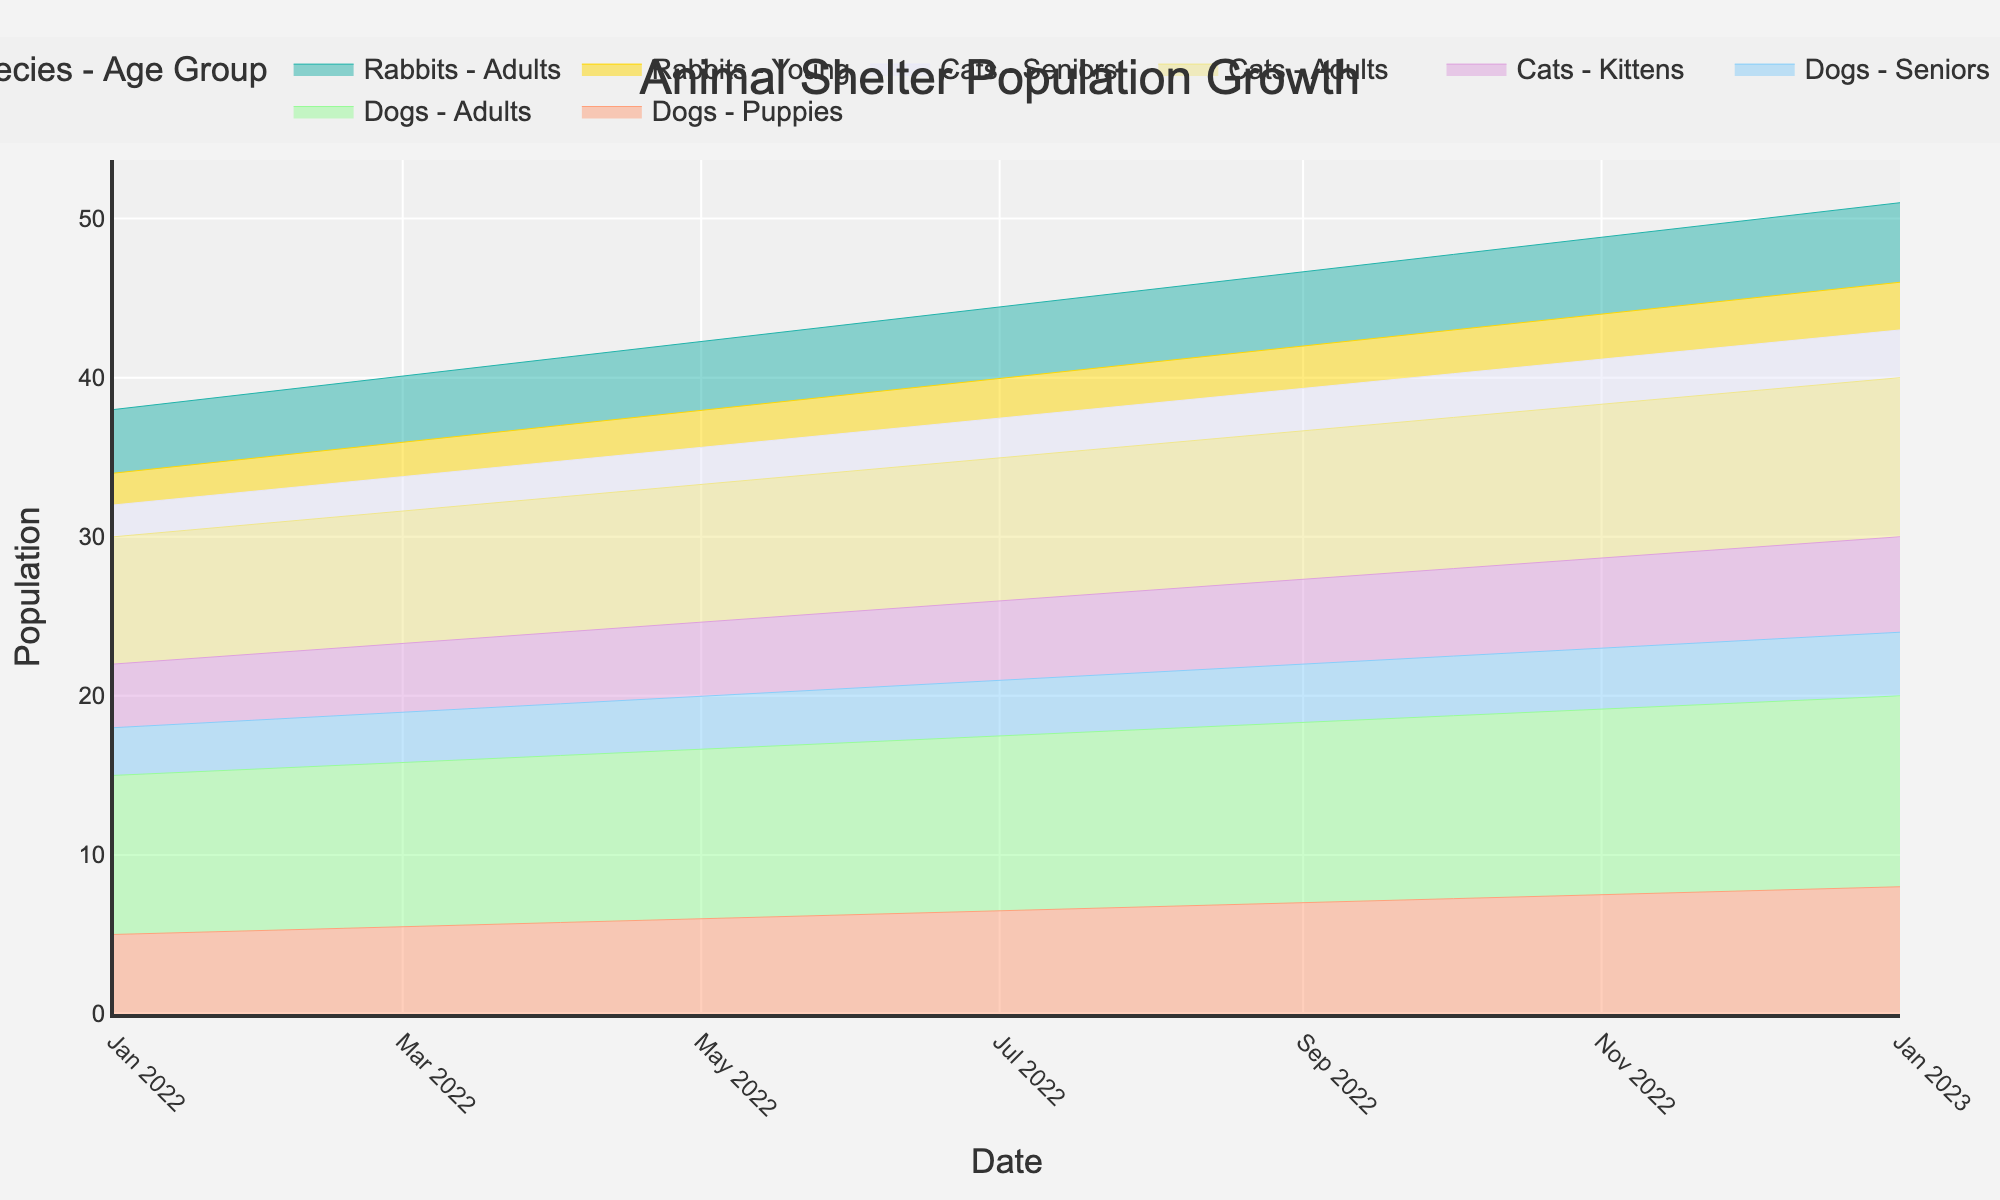What's the title of the figure? The title of the figure is placed at the top and it summarizes the main subject of the graph. Here, it says "Animal Shelter Population Growth".
Answer: Animal Shelter Population Growth What is the population of adult cats on January 1, 2023? Look for the data point on the stream graph under "Cats - Adults" for the date January 1, 2023. The corresponding population value is 10.
Answer: 10 Which species and age group had the highest population on January 1, 2023? Look across the various colored regions on the graph to find the highest line at the date January 1, 2023. The group "Dogs - Adults" had the highest population with a count of 12.
Answer: Dogs - Adults By how many did the population of puppies increase from January 1, 2022 to January 1, 2023? Find the population of puppies under the "Dogs - Puppies" category for both dates. Then, subtract the earlier value (5) from the later value (8). 8 - 5 = 3.
Answer: 3 What is the total population of animals on January 1, 2022? Sum up the individual population numbers for all species and age groups on January 1, 2022. (5+10+3+4+8+2+2+4) = 38.
Answer: 38 Which age group among cats showed the least growth between January 1, 2022 and January 1, 2023? Compare the population change for each cat age group by calculating the differences between the dates. Kittens: 4 to 6 (+2), Adults: 8 to 10 (+2), Seniors: 2 to 3 (+1). "Seniors" had the least growth.
Answer: Seniors How did the population of senior dogs change from January 1, 2022 to January 1, 2023? Look at the values for senior dogs for both dates. From 3 to 4 means an increase.
Answer: Increase What is the combined population of all rabbits on January 1, 2023? Sum the population values for young and adult rabbits on this date. (3+5)=8.
Answer: 8 Are there more adult cats or senior dogs on January 1, 2022? Compare the populations: Adult Cats: 8, Senior Dogs: 3. Adult cats are more numerous.
Answer: Adult cats What is the difference in population between adult and senior animals on January 1, 2022? Sum the numbers for adults and seniors of all species, then find the difference. Adults: 10 (dogs) + 8 (cats) + 4 (rabbits) = 22. Seniors: 3 (dogs) + 2 (cats) = 5. Difference = 22 - 5 = 17.
Answer: 17 